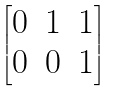Convert formula to latex. <formula><loc_0><loc_0><loc_500><loc_500>\begin{bmatrix} 0 & 1 & 1 \\ 0 & 0 & 1 \end{bmatrix}</formula> 